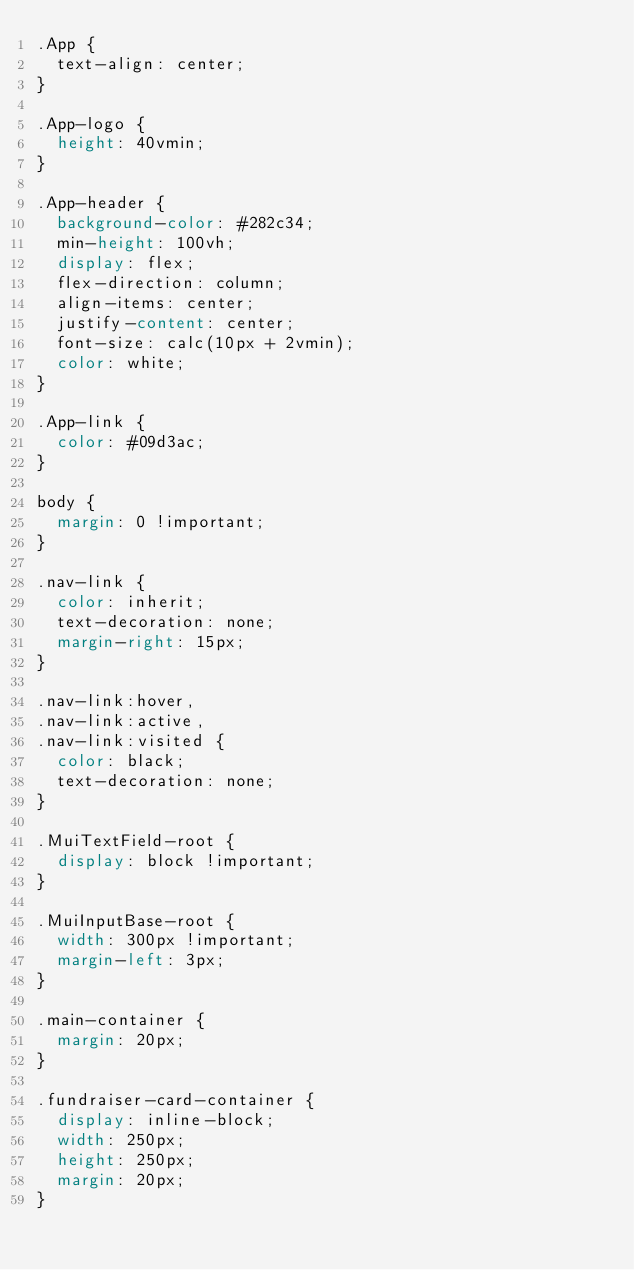Convert code to text. <code><loc_0><loc_0><loc_500><loc_500><_CSS_>.App {
  text-align: center;
}

.App-logo {
  height: 40vmin;
}

.App-header {
  background-color: #282c34;
  min-height: 100vh;
  display: flex;
  flex-direction: column;
  align-items: center;
  justify-content: center;
  font-size: calc(10px + 2vmin);
  color: white;
}

.App-link {
  color: #09d3ac;
}

body {
  margin: 0 !important;
}

.nav-link {
  color: inherit;
  text-decoration: none;
  margin-right: 15px;
}

.nav-link:hover,
.nav-link:active,
.nav-link:visited {
  color: black;
  text-decoration: none;
}

.MuiTextField-root {
  display: block !important;
}

.MuiInputBase-root {
  width: 300px !important;
  margin-left: 3px;
}

.main-container {
  margin: 20px;
}

.fundraiser-card-container {
  display: inline-block;
  width: 250px;
  height: 250px;
  margin: 20px;
}</code> 